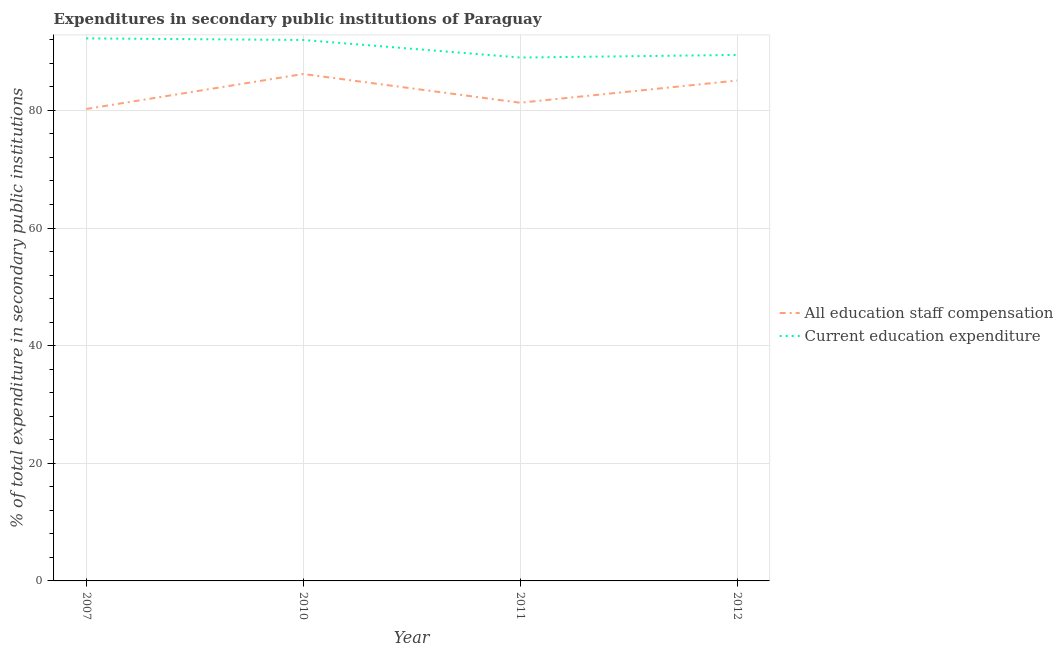How many different coloured lines are there?
Provide a succinct answer. 2. What is the expenditure in education in 2010?
Your response must be concise. 91.97. Across all years, what is the maximum expenditure in staff compensation?
Keep it short and to the point. 86.19. Across all years, what is the minimum expenditure in education?
Provide a succinct answer. 88.99. In which year was the expenditure in staff compensation maximum?
Offer a terse response. 2010. In which year was the expenditure in staff compensation minimum?
Your response must be concise. 2007. What is the total expenditure in staff compensation in the graph?
Offer a terse response. 332.81. What is the difference between the expenditure in staff compensation in 2007 and that in 2011?
Make the answer very short. -1.06. What is the difference between the expenditure in staff compensation in 2012 and the expenditure in education in 2011?
Your answer should be compact. -3.91. What is the average expenditure in education per year?
Give a very brief answer. 90.66. In the year 2011, what is the difference between the expenditure in education and expenditure in staff compensation?
Ensure brevity in your answer.  7.69. In how many years, is the expenditure in staff compensation greater than 4 %?
Ensure brevity in your answer.  4. What is the ratio of the expenditure in staff compensation in 2011 to that in 2012?
Provide a succinct answer. 0.96. Is the expenditure in staff compensation in 2007 less than that in 2012?
Your answer should be very brief. Yes. Is the difference between the expenditure in education in 2011 and 2012 greater than the difference between the expenditure in staff compensation in 2011 and 2012?
Make the answer very short. Yes. What is the difference between the highest and the second highest expenditure in education?
Offer a very short reply. 0.27. What is the difference between the highest and the lowest expenditure in staff compensation?
Your answer should be very brief. 5.95. Is the sum of the expenditure in education in 2007 and 2012 greater than the maximum expenditure in staff compensation across all years?
Offer a terse response. Yes. Does the expenditure in education monotonically increase over the years?
Provide a succinct answer. No. Is the expenditure in staff compensation strictly greater than the expenditure in education over the years?
Your response must be concise. No. How many lines are there?
Ensure brevity in your answer.  2. What is the difference between two consecutive major ticks on the Y-axis?
Your response must be concise. 20. Are the values on the major ticks of Y-axis written in scientific E-notation?
Make the answer very short. No. How many legend labels are there?
Your response must be concise. 2. What is the title of the graph?
Offer a terse response. Expenditures in secondary public institutions of Paraguay. Does "Agricultural land" appear as one of the legend labels in the graph?
Ensure brevity in your answer.  No. What is the label or title of the X-axis?
Keep it short and to the point. Year. What is the label or title of the Y-axis?
Offer a very short reply. % of total expenditure in secondary public institutions. What is the % of total expenditure in secondary public institutions in All education staff compensation in 2007?
Your response must be concise. 80.24. What is the % of total expenditure in secondary public institutions in Current education expenditure in 2007?
Your answer should be very brief. 92.24. What is the % of total expenditure in secondary public institutions in All education staff compensation in 2010?
Provide a short and direct response. 86.19. What is the % of total expenditure in secondary public institutions in Current education expenditure in 2010?
Your answer should be compact. 91.97. What is the % of total expenditure in secondary public institutions in All education staff compensation in 2011?
Give a very brief answer. 81.3. What is the % of total expenditure in secondary public institutions in Current education expenditure in 2011?
Your answer should be compact. 88.99. What is the % of total expenditure in secondary public institutions of All education staff compensation in 2012?
Make the answer very short. 85.08. What is the % of total expenditure in secondary public institutions in Current education expenditure in 2012?
Provide a short and direct response. 89.43. Across all years, what is the maximum % of total expenditure in secondary public institutions in All education staff compensation?
Provide a short and direct response. 86.19. Across all years, what is the maximum % of total expenditure in secondary public institutions in Current education expenditure?
Ensure brevity in your answer.  92.24. Across all years, what is the minimum % of total expenditure in secondary public institutions of All education staff compensation?
Make the answer very short. 80.24. Across all years, what is the minimum % of total expenditure in secondary public institutions in Current education expenditure?
Provide a succinct answer. 88.99. What is the total % of total expenditure in secondary public institutions in All education staff compensation in the graph?
Offer a terse response. 332.81. What is the total % of total expenditure in secondary public institutions in Current education expenditure in the graph?
Provide a short and direct response. 362.62. What is the difference between the % of total expenditure in secondary public institutions in All education staff compensation in 2007 and that in 2010?
Your answer should be compact. -5.95. What is the difference between the % of total expenditure in secondary public institutions in Current education expenditure in 2007 and that in 2010?
Ensure brevity in your answer.  0.27. What is the difference between the % of total expenditure in secondary public institutions in All education staff compensation in 2007 and that in 2011?
Offer a terse response. -1.06. What is the difference between the % of total expenditure in secondary public institutions of Current education expenditure in 2007 and that in 2011?
Your answer should be very brief. 3.25. What is the difference between the % of total expenditure in secondary public institutions of All education staff compensation in 2007 and that in 2012?
Provide a short and direct response. -4.84. What is the difference between the % of total expenditure in secondary public institutions of Current education expenditure in 2007 and that in 2012?
Your response must be concise. 2.81. What is the difference between the % of total expenditure in secondary public institutions in All education staff compensation in 2010 and that in 2011?
Ensure brevity in your answer.  4.89. What is the difference between the % of total expenditure in secondary public institutions of Current education expenditure in 2010 and that in 2011?
Your answer should be compact. 2.98. What is the difference between the % of total expenditure in secondary public institutions in All education staff compensation in 2010 and that in 2012?
Offer a terse response. 1.11. What is the difference between the % of total expenditure in secondary public institutions of Current education expenditure in 2010 and that in 2012?
Keep it short and to the point. 2.54. What is the difference between the % of total expenditure in secondary public institutions of All education staff compensation in 2011 and that in 2012?
Ensure brevity in your answer.  -3.78. What is the difference between the % of total expenditure in secondary public institutions in Current education expenditure in 2011 and that in 2012?
Provide a succinct answer. -0.44. What is the difference between the % of total expenditure in secondary public institutions of All education staff compensation in 2007 and the % of total expenditure in secondary public institutions of Current education expenditure in 2010?
Provide a succinct answer. -11.73. What is the difference between the % of total expenditure in secondary public institutions of All education staff compensation in 2007 and the % of total expenditure in secondary public institutions of Current education expenditure in 2011?
Provide a succinct answer. -8.74. What is the difference between the % of total expenditure in secondary public institutions of All education staff compensation in 2007 and the % of total expenditure in secondary public institutions of Current education expenditure in 2012?
Keep it short and to the point. -9.19. What is the difference between the % of total expenditure in secondary public institutions of All education staff compensation in 2010 and the % of total expenditure in secondary public institutions of Current education expenditure in 2011?
Provide a succinct answer. -2.8. What is the difference between the % of total expenditure in secondary public institutions in All education staff compensation in 2010 and the % of total expenditure in secondary public institutions in Current education expenditure in 2012?
Provide a short and direct response. -3.24. What is the difference between the % of total expenditure in secondary public institutions in All education staff compensation in 2011 and the % of total expenditure in secondary public institutions in Current education expenditure in 2012?
Your answer should be very brief. -8.13. What is the average % of total expenditure in secondary public institutions of All education staff compensation per year?
Provide a succinct answer. 83.2. What is the average % of total expenditure in secondary public institutions in Current education expenditure per year?
Your answer should be very brief. 90.66. In the year 2007, what is the difference between the % of total expenditure in secondary public institutions of All education staff compensation and % of total expenditure in secondary public institutions of Current education expenditure?
Give a very brief answer. -12. In the year 2010, what is the difference between the % of total expenditure in secondary public institutions in All education staff compensation and % of total expenditure in secondary public institutions in Current education expenditure?
Provide a short and direct response. -5.78. In the year 2011, what is the difference between the % of total expenditure in secondary public institutions of All education staff compensation and % of total expenditure in secondary public institutions of Current education expenditure?
Your answer should be very brief. -7.69. In the year 2012, what is the difference between the % of total expenditure in secondary public institutions of All education staff compensation and % of total expenditure in secondary public institutions of Current education expenditure?
Your answer should be very brief. -4.35. What is the ratio of the % of total expenditure in secondary public institutions of Current education expenditure in 2007 to that in 2010?
Your answer should be very brief. 1. What is the ratio of the % of total expenditure in secondary public institutions of Current education expenditure in 2007 to that in 2011?
Provide a succinct answer. 1.04. What is the ratio of the % of total expenditure in secondary public institutions in All education staff compensation in 2007 to that in 2012?
Your response must be concise. 0.94. What is the ratio of the % of total expenditure in secondary public institutions of Current education expenditure in 2007 to that in 2012?
Your answer should be compact. 1.03. What is the ratio of the % of total expenditure in secondary public institutions in All education staff compensation in 2010 to that in 2011?
Offer a terse response. 1.06. What is the ratio of the % of total expenditure in secondary public institutions of Current education expenditure in 2010 to that in 2011?
Offer a terse response. 1.03. What is the ratio of the % of total expenditure in secondary public institutions of All education staff compensation in 2010 to that in 2012?
Provide a short and direct response. 1.01. What is the ratio of the % of total expenditure in secondary public institutions in Current education expenditure in 2010 to that in 2012?
Offer a very short reply. 1.03. What is the ratio of the % of total expenditure in secondary public institutions of All education staff compensation in 2011 to that in 2012?
Offer a very short reply. 0.96. What is the difference between the highest and the second highest % of total expenditure in secondary public institutions in All education staff compensation?
Your answer should be very brief. 1.11. What is the difference between the highest and the second highest % of total expenditure in secondary public institutions of Current education expenditure?
Provide a short and direct response. 0.27. What is the difference between the highest and the lowest % of total expenditure in secondary public institutions in All education staff compensation?
Keep it short and to the point. 5.95. What is the difference between the highest and the lowest % of total expenditure in secondary public institutions in Current education expenditure?
Provide a succinct answer. 3.25. 